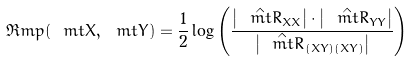<formula> <loc_0><loc_0><loc_500><loc_500>\Re m p ( \ m t X , \ m t Y ) = \frac { 1 } { 2 } \log \left ( \frac { \left | \hat { \ m t R } _ { X X } \right | \cdot \left | \hat { \ m t R } _ { Y Y } \right | } { \left | \hat { \ m t R } _ { ( X Y ) ( X Y ) } \right | } \right )</formula> 